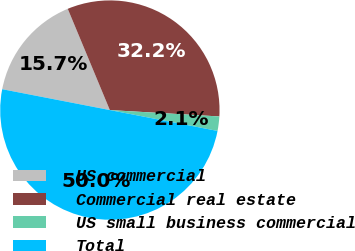Convert chart to OTSL. <chart><loc_0><loc_0><loc_500><loc_500><pie_chart><fcel>US commercial<fcel>Commercial real estate<fcel>US small business commercial<fcel>Total<nl><fcel>15.68%<fcel>32.2%<fcel>2.12%<fcel>50.0%<nl></chart> 